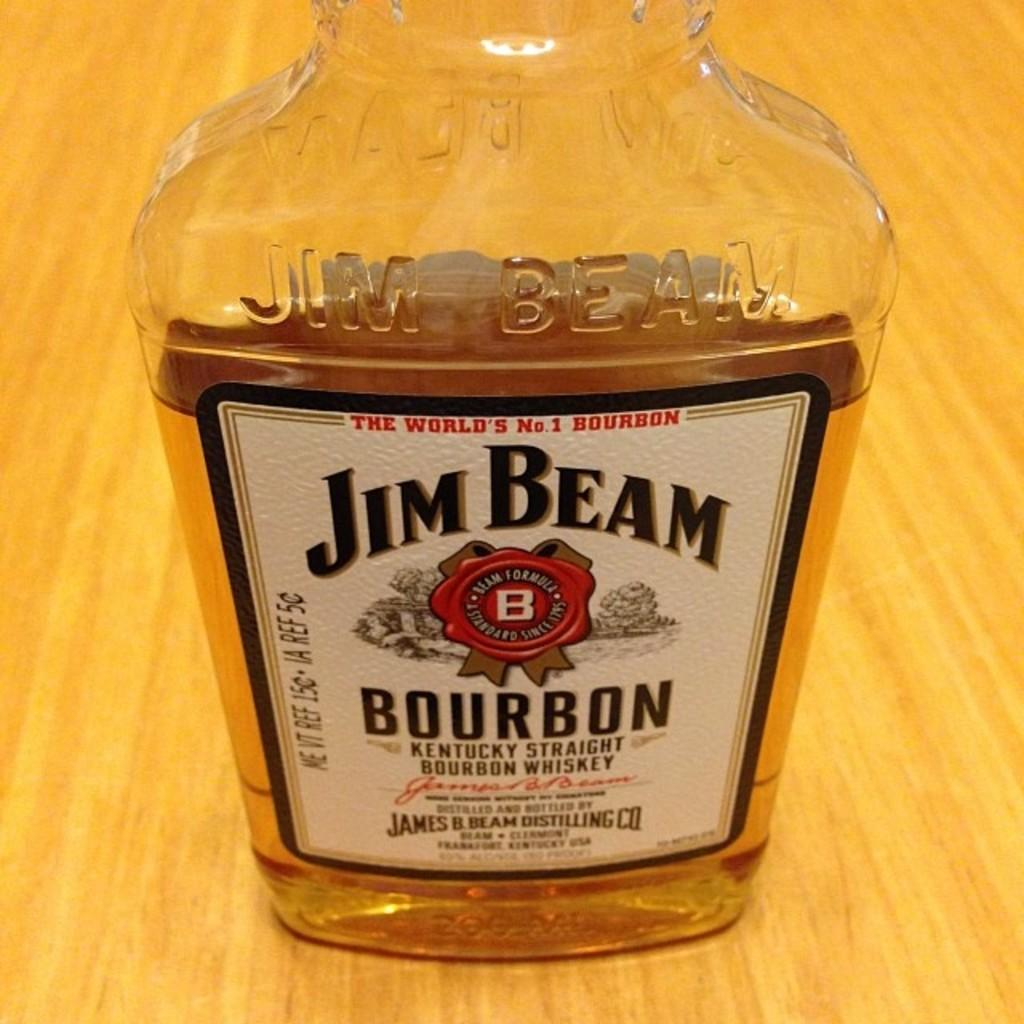<image>
Offer a succinct explanation of the picture presented. A bottle of Jim Beam which is kentuckys straight bourbon whiskey. 